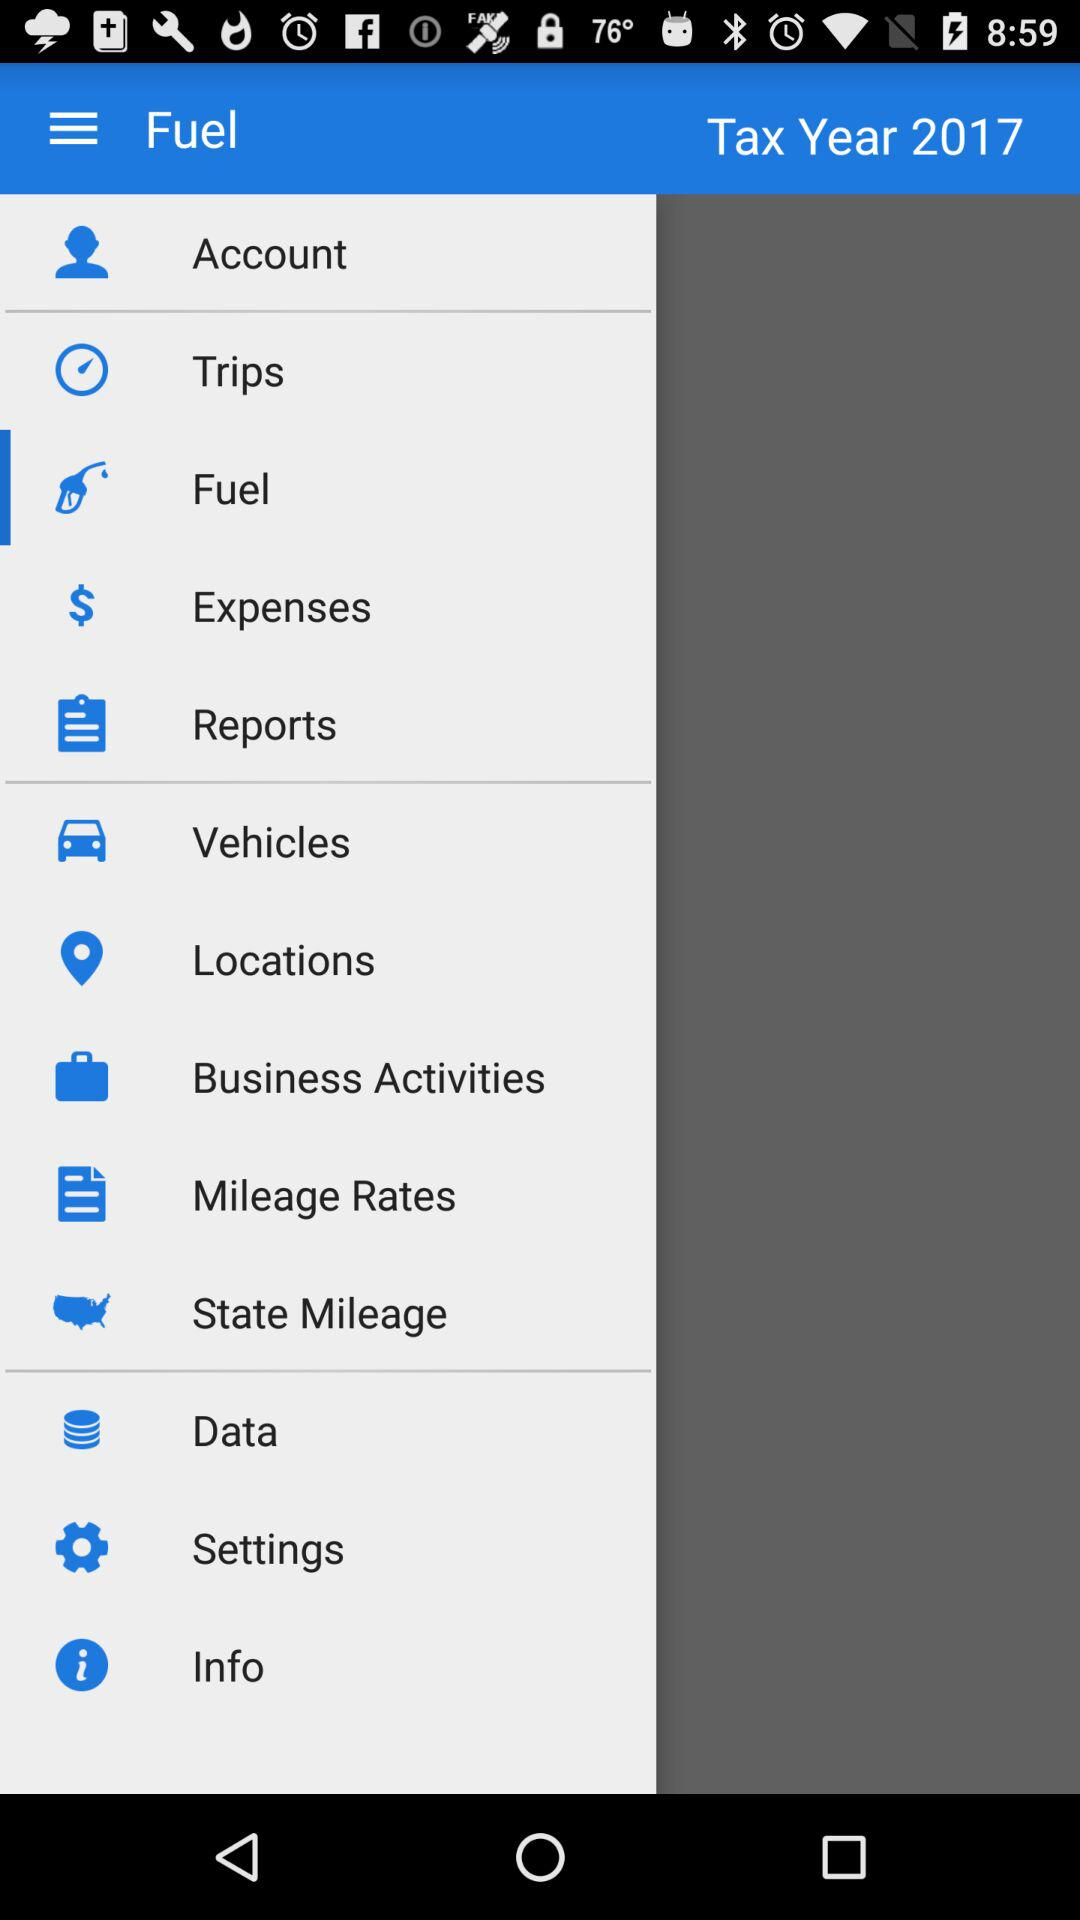How many notifications are there in "Settings"?
When the provided information is insufficient, respond with <no answer>. <no answer> 